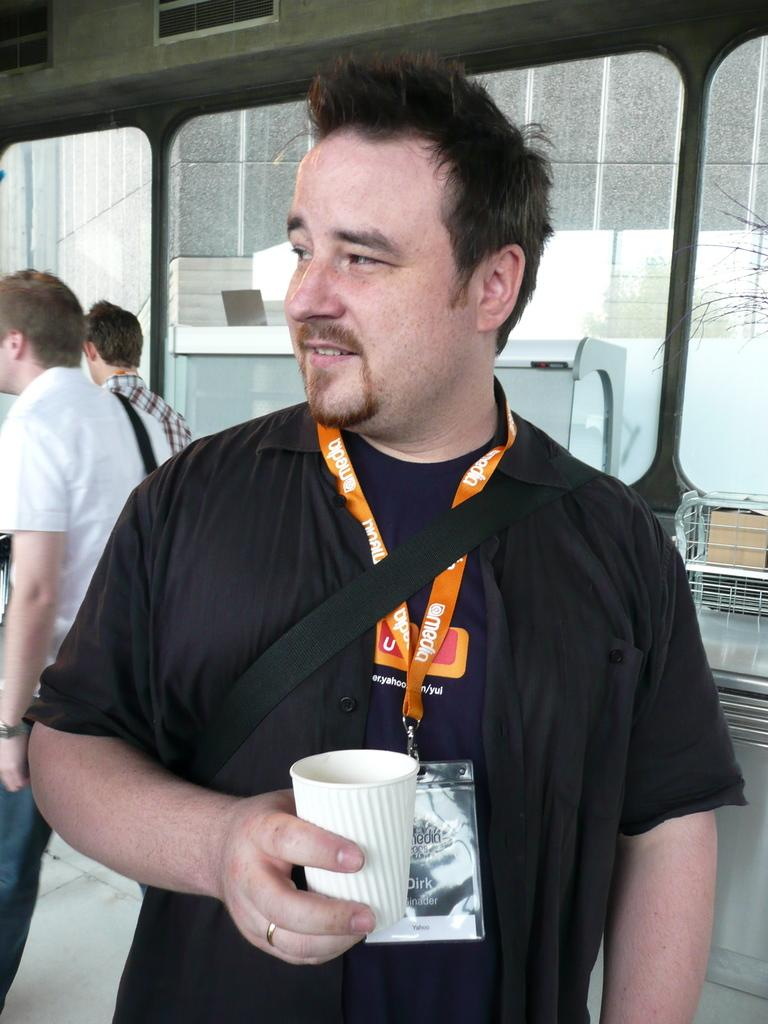What is the man in the image wearing? The man is wearing an ID card. What is the man holding in the image? The man is holding a cup. Can you describe the background of the image? There are two people and a wall in the background of the image, along with some visible objects. What type of cheese can be seen on the wall in the image? There is no cheese present in the image; the wall is part of the background and does not have any cheese on it. 